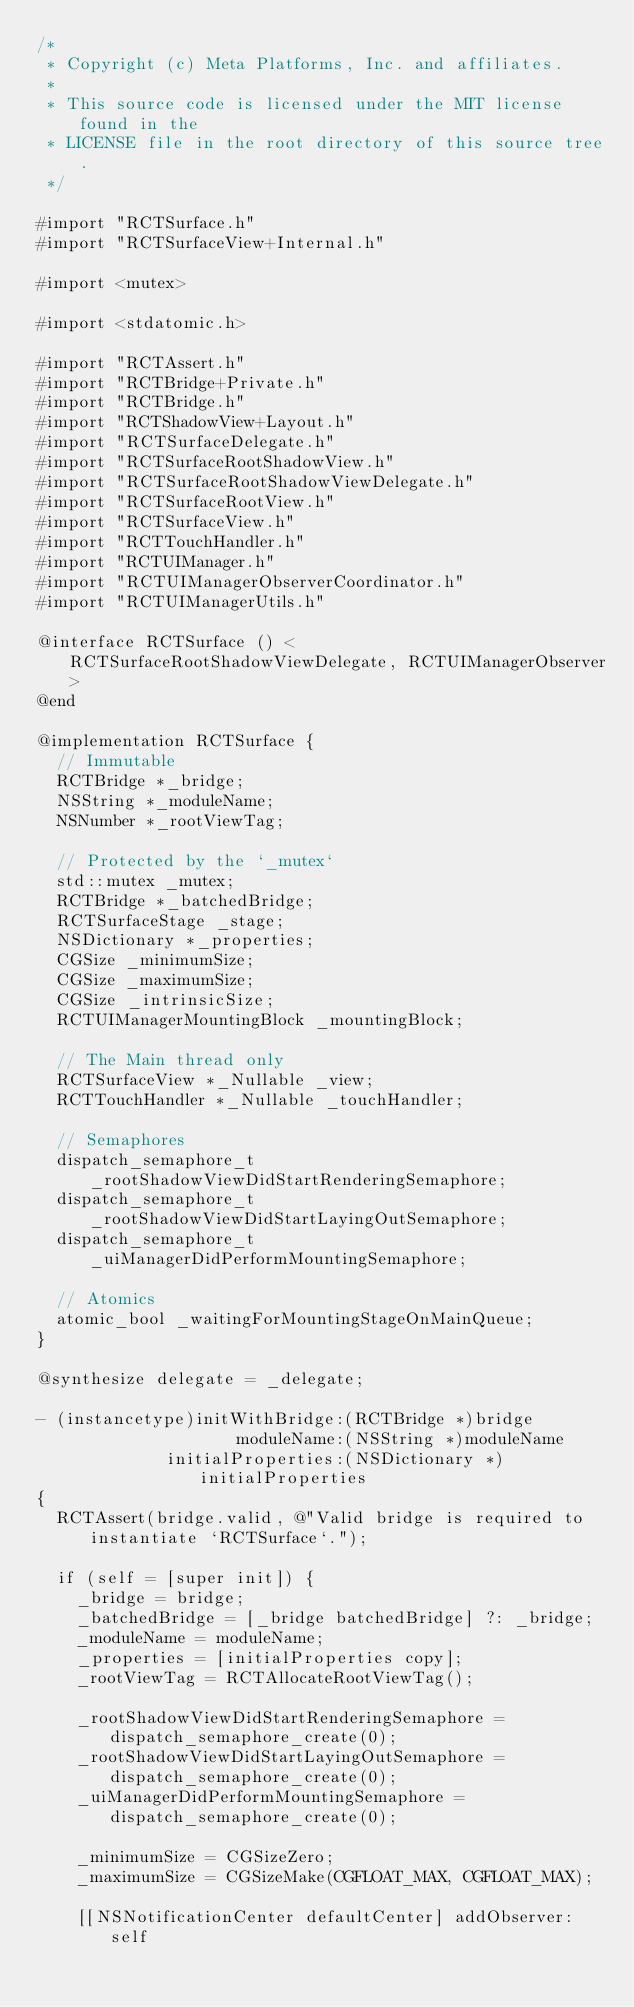Convert code to text. <code><loc_0><loc_0><loc_500><loc_500><_ObjectiveC_>/*
 * Copyright (c) Meta Platforms, Inc. and affiliates.
 *
 * This source code is licensed under the MIT license found in the
 * LICENSE file in the root directory of this source tree.
 */

#import "RCTSurface.h"
#import "RCTSurfaceView+Internal.h"

#import <mutex>

#import <stdatomic.h>

#import "RCTAssert.h"
#import "RCTBridge+Private.h"
#import "RCTBridge.h"
#import "RCTShadowView+Layout.h"
#import "RCTSurfaceDelegate.h"
#import "RCTSurfaceRootShadowView.h"
#import "RCTSurfaceRootShadowViewDelegate.h"
#import "RCTSurfaceRootView.h"
#import "RCTSurfaceView.h"
#import "RCTTouchHandler.h"
#import "RCTUIManager.h"
#import "RCTUIManagerObserverCoordinator.h"
#import "RCTUIManagerUtils.h"

@interface RCTSurface () <RCTSurfaceRootShadowViewDelegate, RCTUIManagerObserver>
@end

@implementation RCTSurface {
  // Immutable
  RCTBridge *_bridge;
  NSString *_moduleName;
  NSNumber *_rootViewTag;

  // Protected by the `_mutex`
  std::mutex _mutex;
  RCTBridge *_batchedBridge;
  RCTSurfaceStage _stage;
  NSDictionary *_properties;
  CGSize _minimumSize;
  CGSize _maximumSize;
  CGSize _intrinsicSize;
  RCTUIManagerMountingBlock _mountingBlock;

  // The Main thread only
  RCTSurfaceView *_Nullable _view;
  RCTTouchHandler *_Nullable _touchHandler;

  // Semaphores
  dispatch_semaphore_t _rootShadowViewDidStartRenderingSemaphore;
  dispatch_semaphore_t _rootShadowViewDidStartLayingOutSemaphore;
  dispatch_semaphore_t _uiManagerDidPerformMountingSemaphore;

  // Atomics
  atomic_bool _waitingForMountingStageOnMainQueue;
}

@synthesize delegate = _delegate;

- (instancetype)initWithBridge:(RCTBridge *)bridge
                    moduleName:(NSString *)moduleName
             initialProperties:(NSDictionary *)initialProperties
{
  RCTAssert(bridge.valid, @"Valid bridge is required to instantiate `RCTSurface`.");

  if (self = [super init]) {
    _bridge = bridge;
    _batchedBridge = [_bridge batchedBridge] ?: _bridge;
    _moduleName = moduleName;
    _properties = [initialProperties copy];
    _rootViewTag = RCTAllocateRootViewTag();

    _rootShadowViewDidStartRenderingSemaphore = dispatch_semaphore_create(0);
    _rootShadowViewDidStartLayingOutSemaphore = dispatch_semaphore_create(0);
    _uiManagerDidPerformMountingSemaphore = dispatch_semaphore_create(0);

    _minimumSize = CGSizeZero;
    _maximumSize = CGSizeMake(CGFLOAT_MAX, CGFLOAT_MAX);

    [[NSNotificationCenter defaultCenter] addObserver:self</code> 